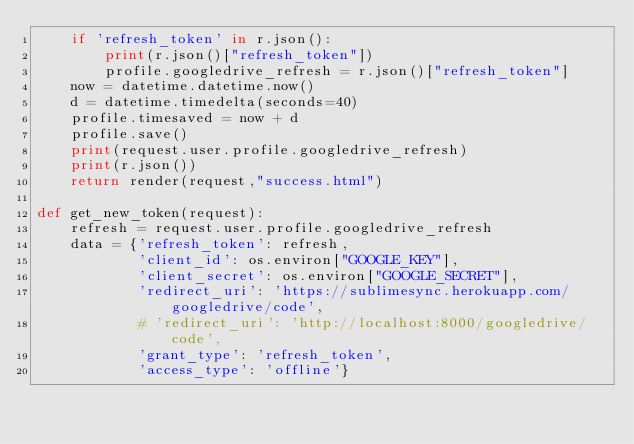<code> <loc_0><loc_0><loc_500><loc_500><_Python_>    if 'refresh_token' in r.json():
        print(r.json()["refresh_token"])
        profile.googledrive_refresh = r.json()["refresh_token"]
    now = datetime.datetime.now()
    d = datetime.timedelta(seconds=40)
    profile.timesaved = now + d
    profile.save()
    print(request.user.profile.googledrive_refresh)
    print(r.json())
    return render(request,"success.html")

def get_new_token(request):
    refresh = request.user.profile.googledrive_refresh
    data = {'refresh_token': refresh,
            'client_id': os.environ["GOOGLE_KEY"],
            'client_secret': os.environ["GOOGLE_SECRET"],
            'redirect_uri': 'https://sublimesync.herokuapp.com/googledrive/code',
            # 'redirect_uri': 'http://localhost:8000/googledrive/code',
            'grant_type': 'refresh_token',
            'access_type': 'offline'}</code> 